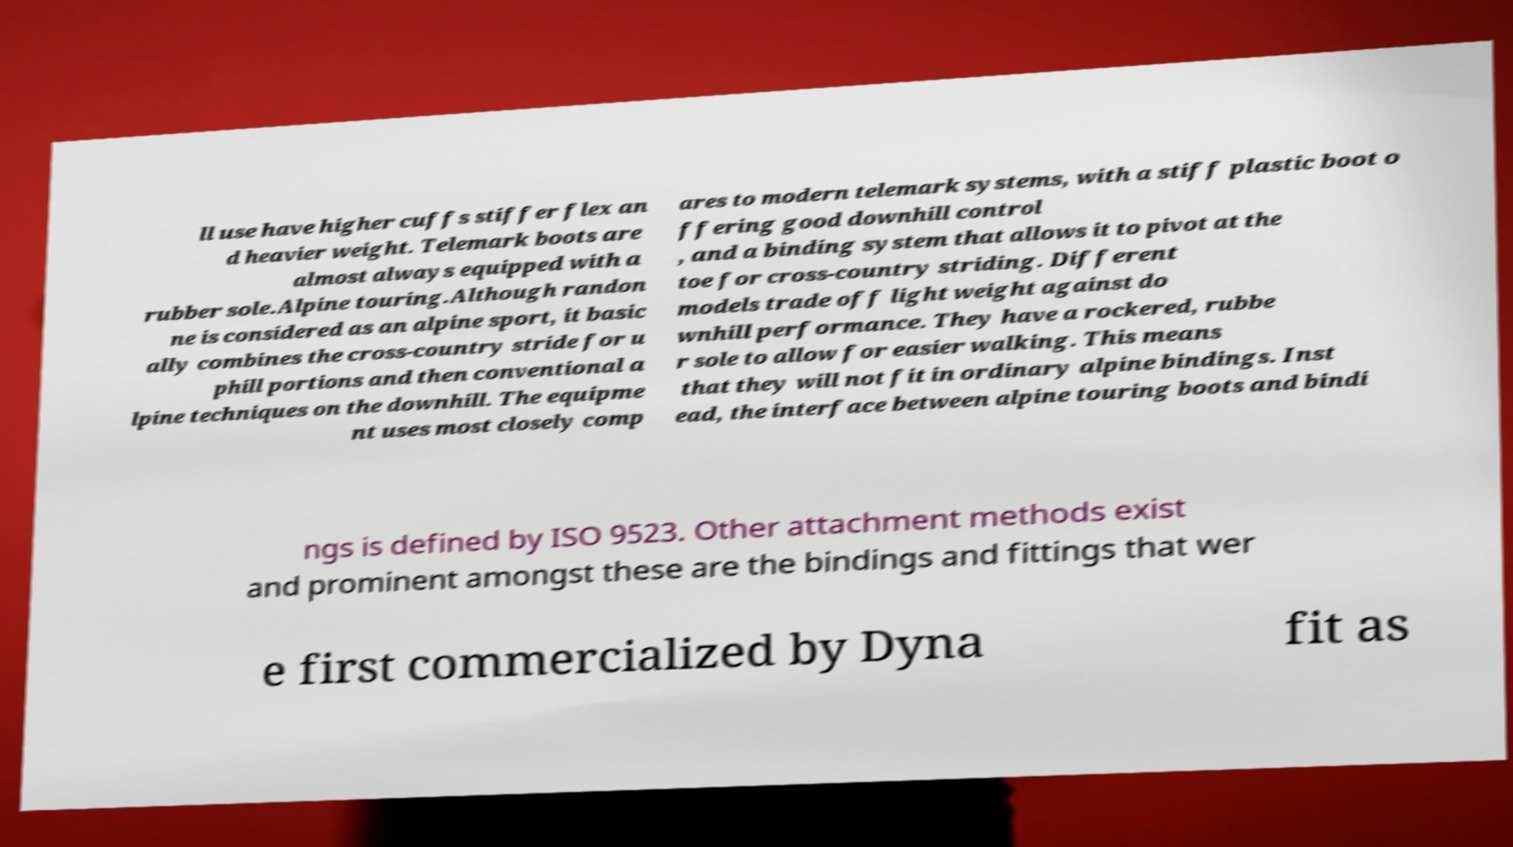Please read and relay the text visible in this image. What does it say? ll use have higher cuffs stiffer flex an d heavier weight. Telemark boots are almost always equipped with a rubber sole.Alpine touring.Although randon ne is considered as an alpine sport, it basic ally combines the cross-country stride for u phill portions and then conventional a lpine techniques on the downhill. The equipme nt uses most closely comp ares to modern telemark systems, with a stiff plastic boot o ffering good downhill control , and a binding system that allows it to pivot at the toe for cross-country striding. Different models trade off light weight against do wnhill performance. They have a rockered, rubbe r sole to allow for easier walking. This means that they will not fit in ordinary alpine bindings. Inst ead, the interface between alpine touring boots and bindi ngs is defined by ISO 9523. Other attachment methods exist and prominent amongst these are the bindings and fittings that wer e first commercialized by Dyna fit as 